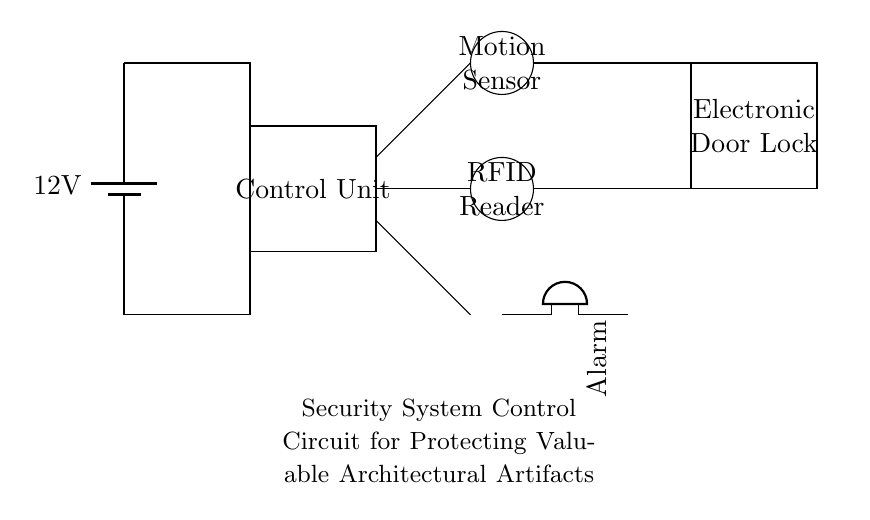What is the main component of this circuit? The main component is the Control Unit, as indicated by the rectangular box labeled "Control Unit" that coordinates the security operations.
Answer: Control Unit What is the voltage level supplied to the circuit? The voltage level is 12 volts, which is shown by the battery symbol in the circuit diagram where "12V" is labeled.
Answer: 12 volts How many types of sensors are in the circuit? There are two types of sensors: a Motion Sensor and an RFID Reader, each represented by a small circle in the diagram.
Answer: Two What component triggers the alarm in the circuit? The component that triggers the alarm is the Motion Sensor, as it detects movement and sends a signal to activate the alarm system.
Answer: Motion Sensor Which component is responsible for securing the doors? The Electronic Door Lock is responsible for securing the doors, as shown by its rectangular representation in the circuit connected to the control unit.
Answer: Electronic Door Lock What happens when the RFID Reader identifies an authorized user? When the RFID Reader identifies an authorized user, it likely informs the Control Unit to disable the Electronic Door Lock, allowing entry.
Answer: Disable Electronic Door Lock What is the role of the alarm in this security system? The role of the alarm is to alert in case of unauthorized access or suspicious movement detected by the Motion Sensor, serving as a deterrent and notification mechanism.
Answer: Alert 